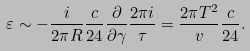Convert formula to latex. <formula><loc_0><loc_0><loc_500><loc_500>\varepsilon & \sim - \frac { i } { 2 \pi R } \frac { c } { 2 4 } \frac { \partial } { \partial \gamma } \frac { 2 \pi { i } } { \tau } = \frac { 2 \pi T ^ { 2 } } { v } \frac { c } { 2 4 } .</formula> 